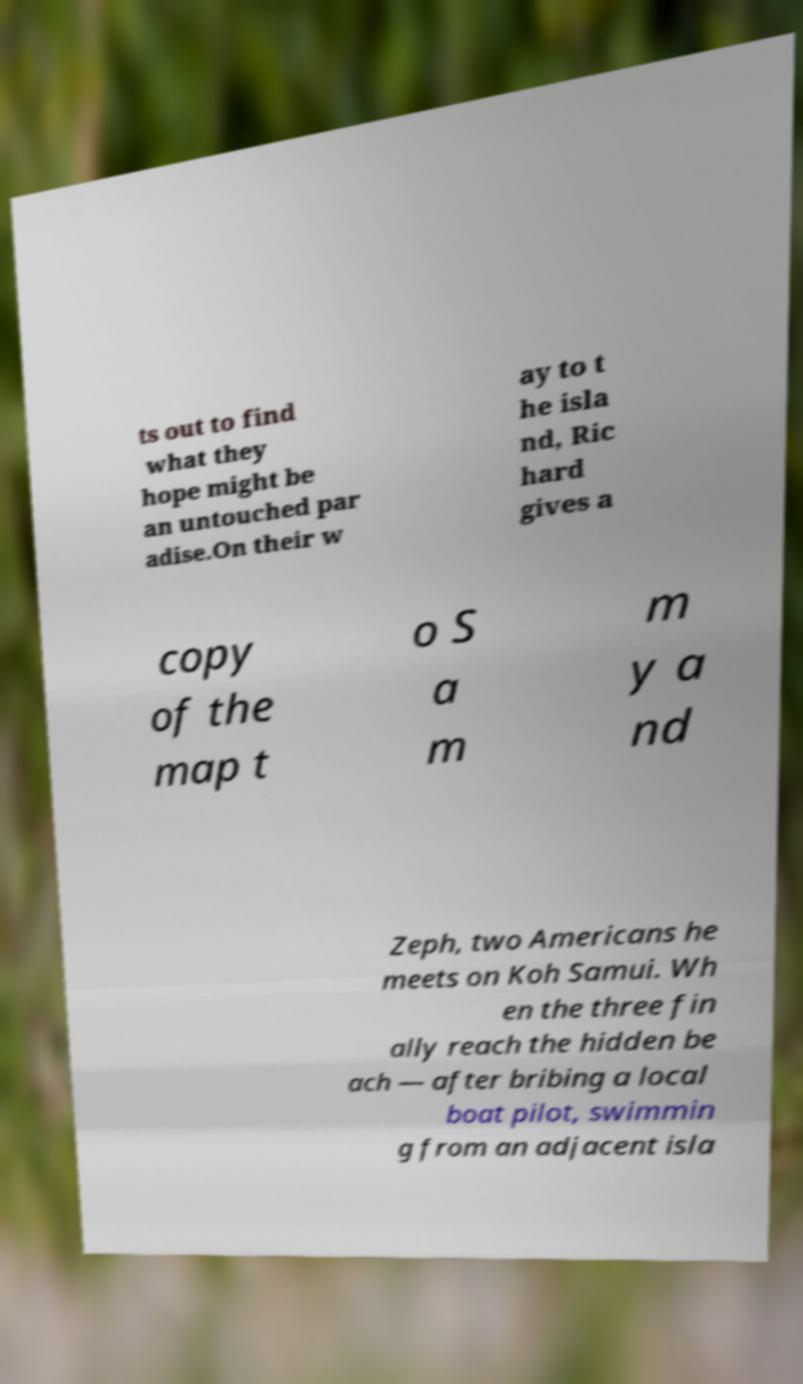Please identify and transcribe the text found in this image. ts out to find what they hope might be an untouched par adise.On their w ay to t he isla nd, Ric hard gives a copy of the map t o S a m m y a nd Zeph, two Americans he meets on Koh Samui. Wh en the three fin ally reach the hidden be ach — after bribing a local boat pilot, swimmin g from an adjacent isla 